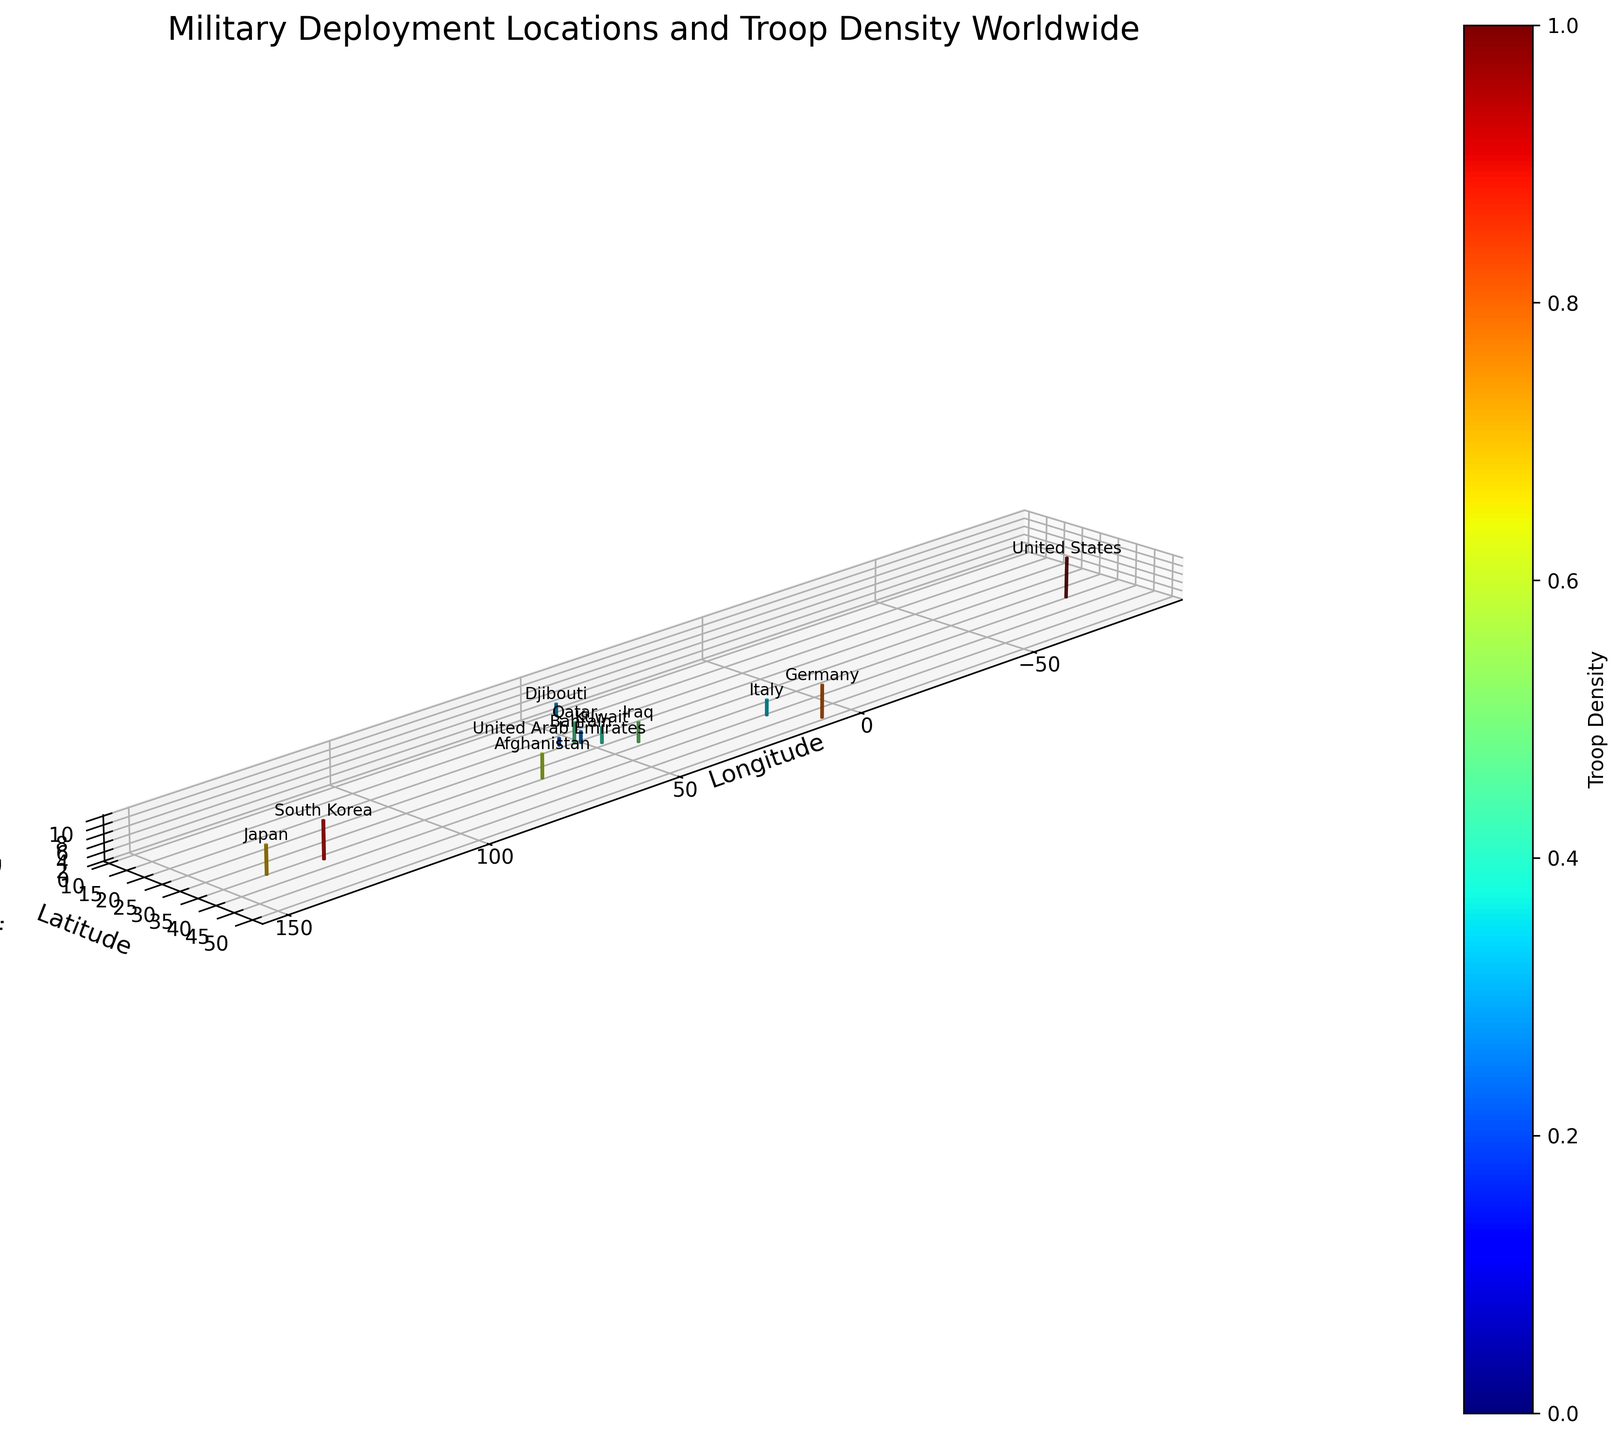What's the title of the figure? The title of the figure is displayed at the top and usually provides a summary of the visual representation. Here, it's clearly labeled above the plot.
Answer: Military Deployment Locations and Troop Density Worldwide Which axis represents troop density? The z-axis holds the label specifying it represents "Troop Density", which is also marked with tick marks indicating varying density levels.
Answer: z-axis How many countries are represented by voxels in this figure? Each country is represented by a labeled voxel, with its name shown alongside. Counting these text labels provides the total number of countries.
Answer: 12 Which location has the highest troop density? The height of the voxels corresponds to troop density, so the tallest voxel indicates the highest density. Fort Bragg in the USA has the tallest voxel.
Answer: Fort Bragg, USA Which two locations have the same troop density and what is that value? By observing the voxel heights and comparing labels, we see that the voxel heights for Camp Lemonnier in Djibouti and Naval Support Activity Bahrain in Bahrain are the same. Both have a troop density of 3 units.
Answer: Camp Lemonnier and Naval Support Activity Bahrain, 3 How does the troop density in Japan compare to that in Germany? Comparing the height of the voxels labeled for Yokosuka Naval Base (Japan) and Ramstein Air Base (Germany) reveals that Japan has a slightly lower height. Germany's height is 8, whereas Japan's height is 7.
Answer: Japan has lower troop density than Germany What is the average troop density of all locations? To find the average: sum up all the troop density values (100 + 80 + 70 + 90 + 60 + 50 + 40 + 30 + 35 + 25 + 20 + 45 = 645) and divide by the number of locations (12).
Answer: 53.75 What is the total voxel height for all locations in the Middle East? Middle East locations include Iraq, Bahrain, UAE, and Qatar. Summing their heights: Al Asad Airbase (5), Naval Support Activity Bahrain (3), Al Dhafra Air Base (2), Al Udeid Air Base (5) results in a total height of 15.
Answer: 15 Which location has the smallest representation in troop density, and where is it located? The shortest voxel indicates the smallest troop density. The location labeled Al Dhafra Air Base in UAE has the shortest voxel with a height of 2.
Answer: Al Dhafra Air Base, UAE 